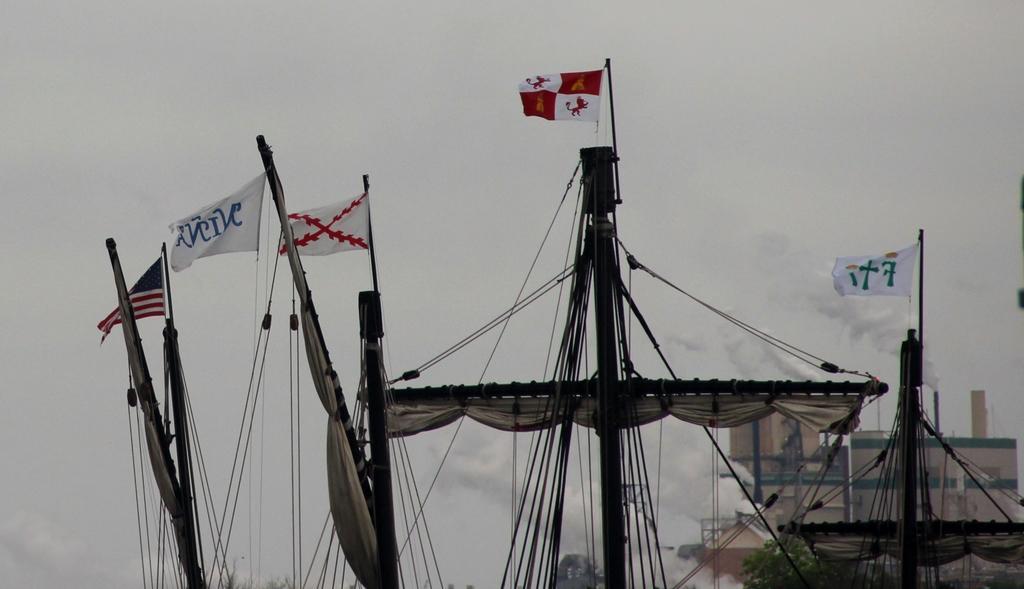Can you describe this image briefly? In this image we can see the sails of a boat, to it there are flags. We can also see that there are ropes which are tied to it. In the background there is a building through which the smoke is emitted. 